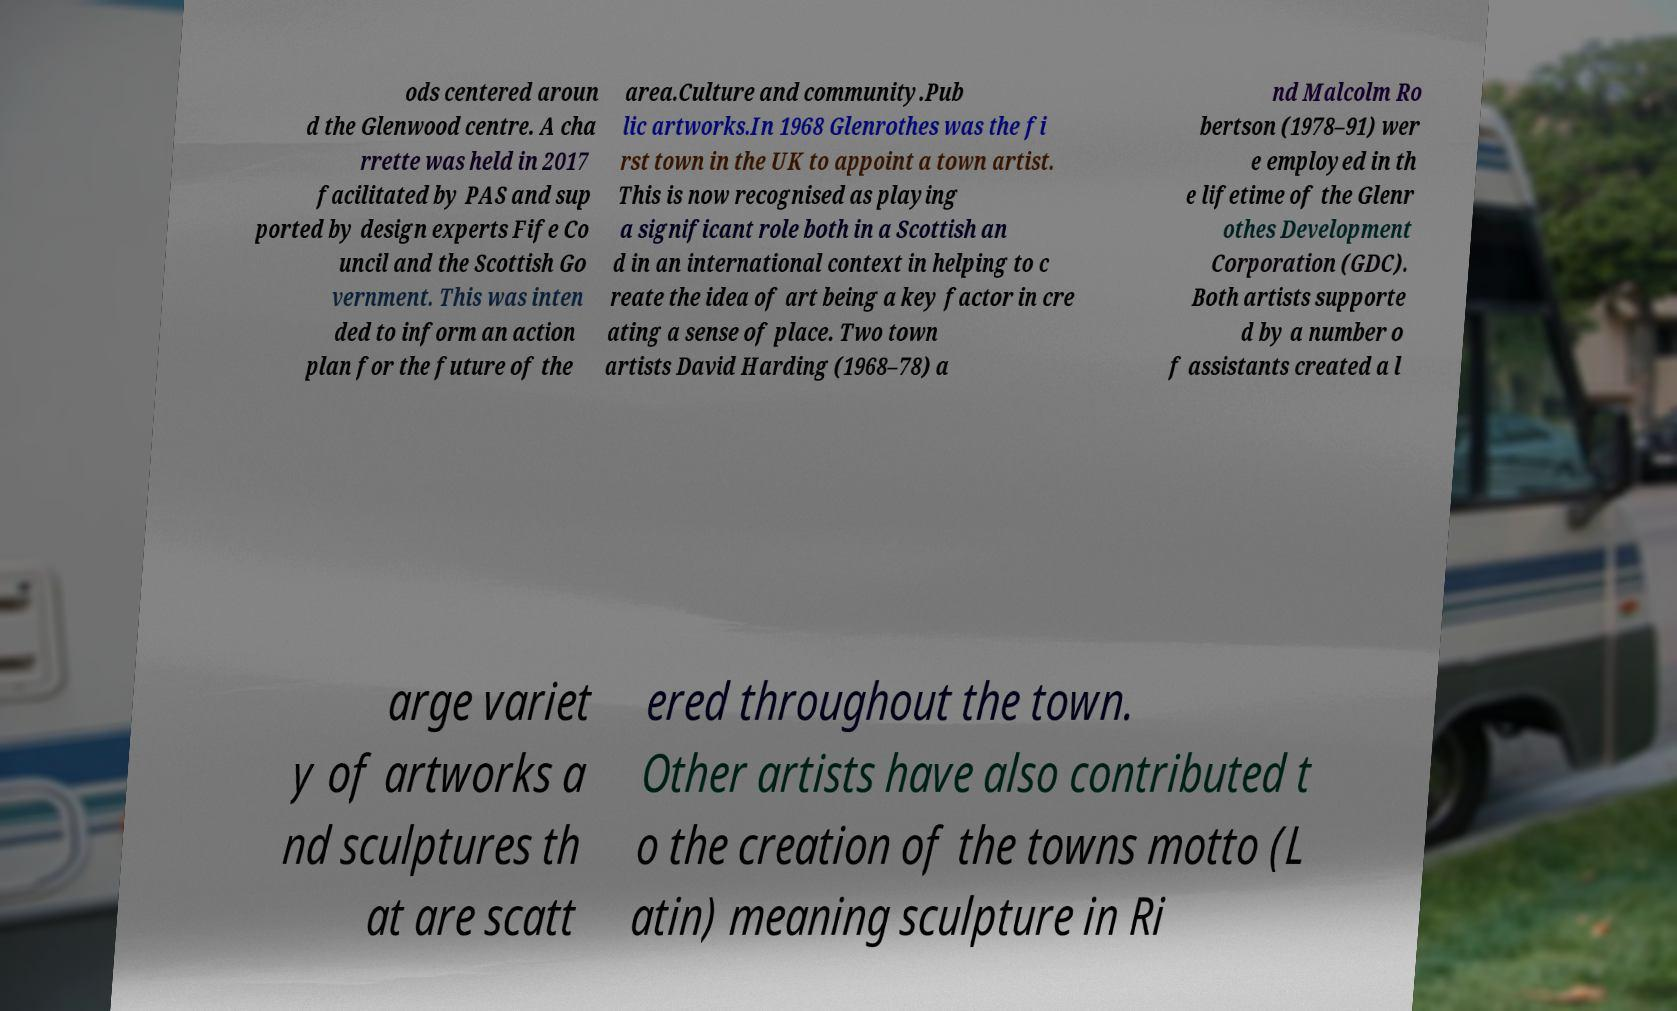What messages or text are displayed in this image? I need them in a readable, typed format. ods centered aroun d the Glenwood centre. A cha rrette was held in 2017 facilitated by PAS and sup ported by design experts Fife Co uncil and the Scottish Go vernment. This was inten ded to inform an action plan for the future of the area.Culture and community.Pub lic artworks.In 1968 Glenrothes was the fi rst town in the UK to appoint a town artist. This is now recognised as playing a significant role both in a Scottish an d in an international context in helping to c reate the idea of art being a key factor in cre ating a sense of place. Two town artists David Harding (1968–78) a nd Malcolm Ro bertson (1978–91) wer e employed in th e lifetime of the Glenr othes Development Corporation (GDC). Both artists supporte d by a number o f assistants created a l arge variet y of artworks a nd sculptures th at are scatt ered throughout the town. Other artists have also contributed t o the creation of the towns motto (L atin) meaning sculpture in Ri 